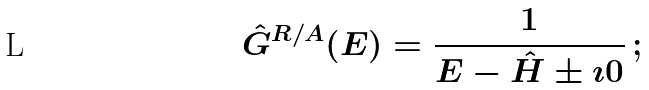<formula> <loc_0><loc_0><loc_500><loc_500>\hat { G } ^ { R / A } ( E ) = \frac { 1 } { E - \hat { H } \pm \imath 0 } \, ;</formula> 